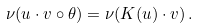<formula> <loc_0><loc_0><loc_500><loc_500>\nu ( u \cdot v \circ \theta ) = \nu ( K ( u ) \cdot v ) \, .</formula> 